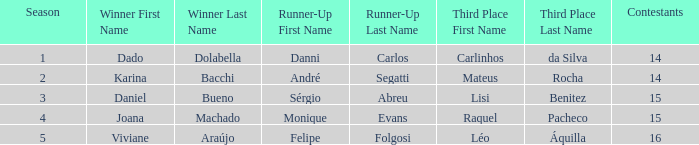Who was the winner when Mateus Rocha finished in 3rd place?  Karina Bacchi. 